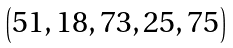<formula> <loc_0><loc_0><loc_500><loc_500>\begin{pmatrix} 5 1 , 1 8 , 7 3 , 2 5 , 7 5 \end{pmatrix}</formula> 